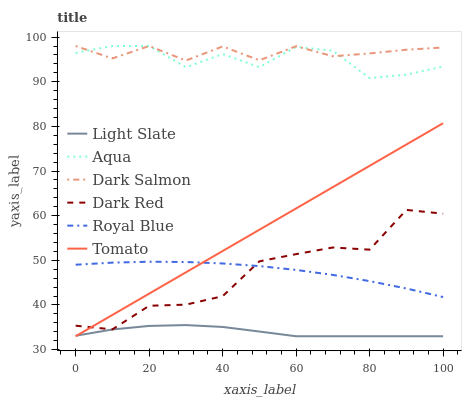Does Light Slate have the minimum area under the curve?
Answer yes or no. Yes. Does Dark Salmon have the maximum area under the curve?
Answer yes or no. Yes. Does Dark Red have the minimum area under the curve?
Answer yes or no. No. Does Dark Red have the maximum area under the curve?
Answer yes or no. No. Is Tomato the smoothest?
Answer yes or no. Yes. Is Dark Red the roughest?
Answer yes or no. Yes. Is Light Slate the smoothest?
Answer yes or no. No. Is Light Slate the roughest?
Answer yes or no. No. Does Tomato have the lowest value?
Answer yes or no. Yes. Does Dark Red have the lowest value?
Answer yes or no. No. Does Dark Salmon have the highest value?
Answer yes or no. Yes. Does Dark Red have the highest value?
Answer yes or no. No. Is Royal Blue less than Aqua?
Answer yes or no. Yes. Is Royal Blue greater than Light Slate?
Answer yes or no. Yes. Does Aqua intersect Dark Salmon?
Answer yes or no. Yes. Is Aqua less than Dark Salmon?
Answer yes or no. No. Is Aqua greater than Dark Salmon?
Answer yes or no. No. Does Royal Blue intersect Aqua?
Answer yes or no. No. 